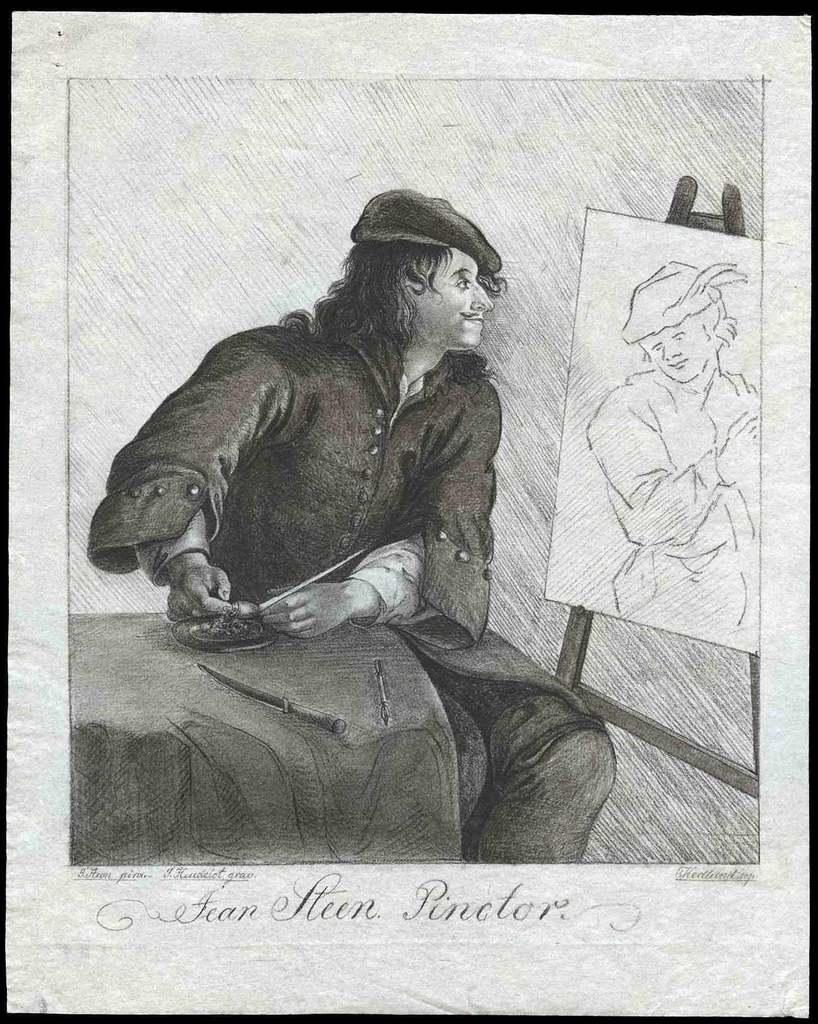What is the main object in the image? There is a frame in the image. What is inside the frame? There is a drawing inside the frame. Are there any letters or symbols visible in the image? Yes, there are alphabets present in the image. What type of trip is being planned in the image? There is no indication of a trip being planned in the image; it features a frame with a drawing and alphabets. What type of secretary is depicted in the image? There is no secretary depicted in the image; it only contains a frame, a drawing, and alphabets. 